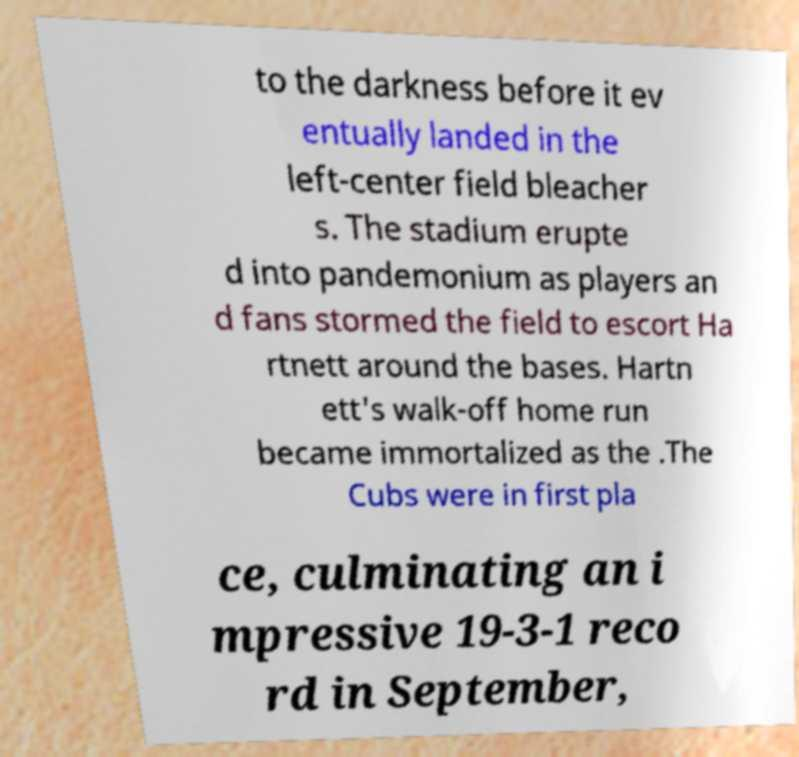Please identify and transcribe the text found in this image. to the darkness before it ev entually landed in the left-center field bleacher s. The stadium erupte d into pandemonium as players an d fans stormed the field to escort Ha rtnett around the bases. Hartn ett's walk-off home run became immortalized as the .The Cubs were in first pla ce, culminating an i mpressive 19-3-1 reco rd in September, 